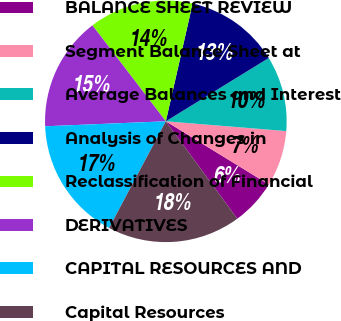Convert chart to OTSL. <chart><loc_0><loc_0><loc_500><loc_500><pie_chart><fcel>BALANCE SHEET REVIEW<fcel>Segment Balance Sheet at<fcel>Average Balances and Interest<fcel>Analysis of Changes in<fcel>Reclassification of Financial<fcel>DERIVATIVES<fcel>CAPITAL RESOURCES AND<fcel>Capital Resources<nl><fcel>6.17%<fcel>7.47%<fcel>10.07%<fcel>12.66%<fcel>13.96%<fcel>15.26%<fcel>16.56%<fcel>17.85%<nl></chart> 